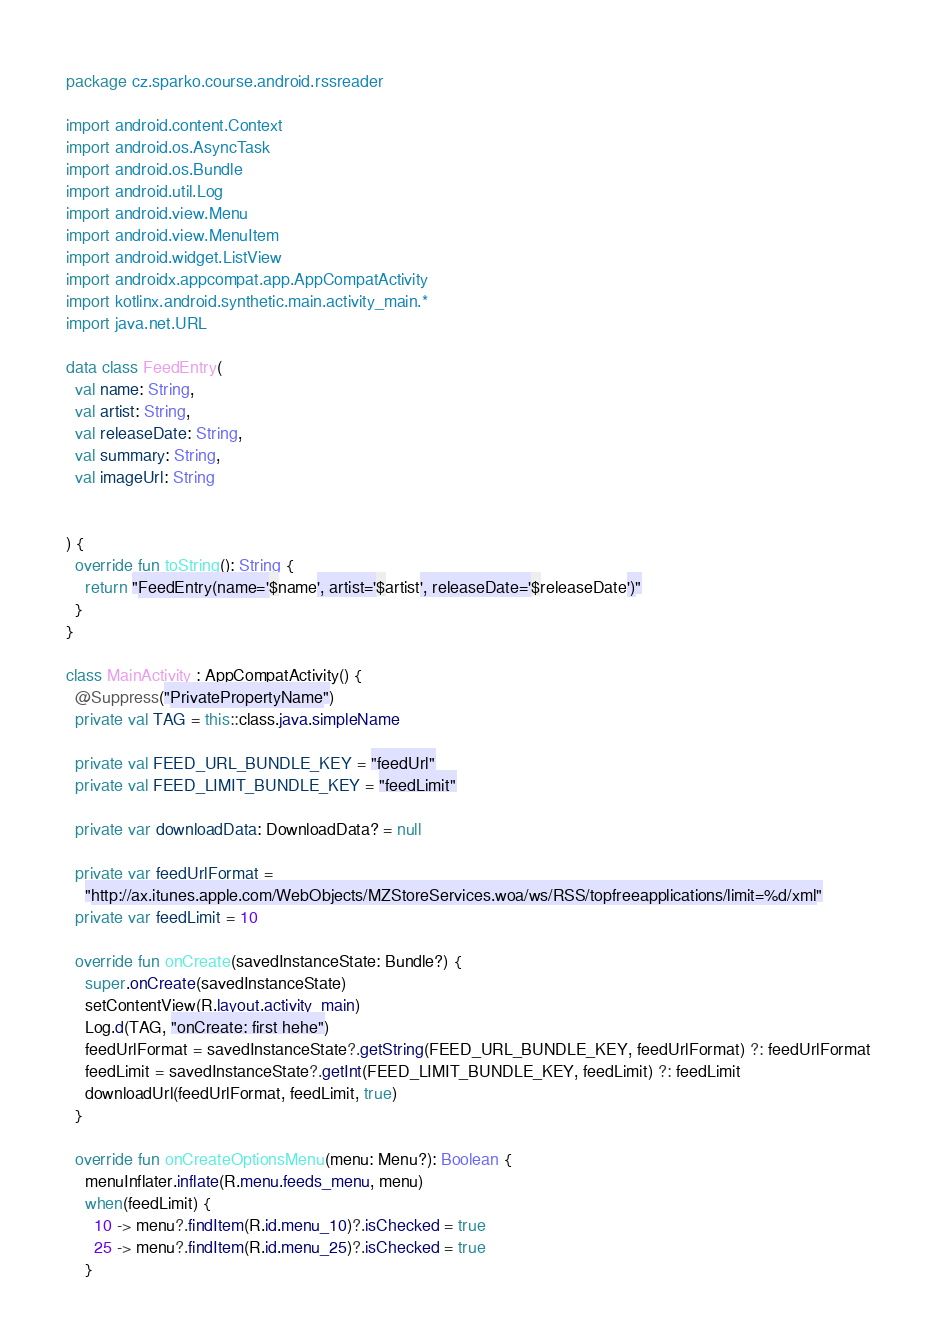<code> <loc_0><loc_0><loc_500><loc_500><_Kotlin_>package cz.sparko.course.android.rssreader

import android.content.Context
import android.os.AsyncTask
import android.os.Bundle
import android.util.Log
import android.view.Menu
import android.view.MenuItem
import android.widget.ListView
import androidx.appcompat.app.AppCompatActivity
import kotlinx.android.synthetic.main.activity_main.*
import java.net.URL

data class FeedEntry(
  val name: String,
  val artist: String,
  val releaseDate: String,
  val summary: String,
  val imageUrl: String


) {
  override fun toString(): String {
    return "FeedEntry(name='$name', artist='$artist', releaseDate='$releaseDate')"
  }
}

class MainActivity : AppCompatActivity() {
  @Suppress("PrivatePropertyName")
  private val TAG = this::class.java.simpleName

  private val FEED_URL_BUNDLE_KEY = "feedUrl"
  private val FEED_LIMIT_BUNDLE_KEY = "feedLimit"

  private var downloadData: DownloadData? = null

  private var feedUrlFormat =
    "http://ax.itunes.apple.com/WebObjects/MZStoreServices.woa/ws/RSS/topfreeapplications/limit=%d/xml"
  private var feedLimit = 10

  override fun onCreate(savedInstanceState: Bundle?) {
    super.onCreate(savedInstanceState)
    setContentView(R.layout.activity_main)
    Log.d(TAG, "onCreate: first hehe")
    feedUrlFormat = savedInstanceState?.getString(FEED_URL_BUNDLE_KEY, feedUrlFormat) ?: feedUrlFormat
    feedLimit = savedInstanceState?.getInt(FEED_LIMIT_BUNDLE_KEY, feedLimit) ?: feedLimit
    downloadUrl(feedUrlFormat, feedLimit, true)
  }

  override fun onCreateOptionsMenu(menu: Menu?): Boolean {
    menuInflater.inflate(R.menu.feeds_menu, menu)
    when(feedLimit) {
      10 -> menu?.findItem(R.id.menu_10)?.isChecked = true
      25 -> menu?.findItem(R.id.menu_25)?.isChecked = true
    }</code> 